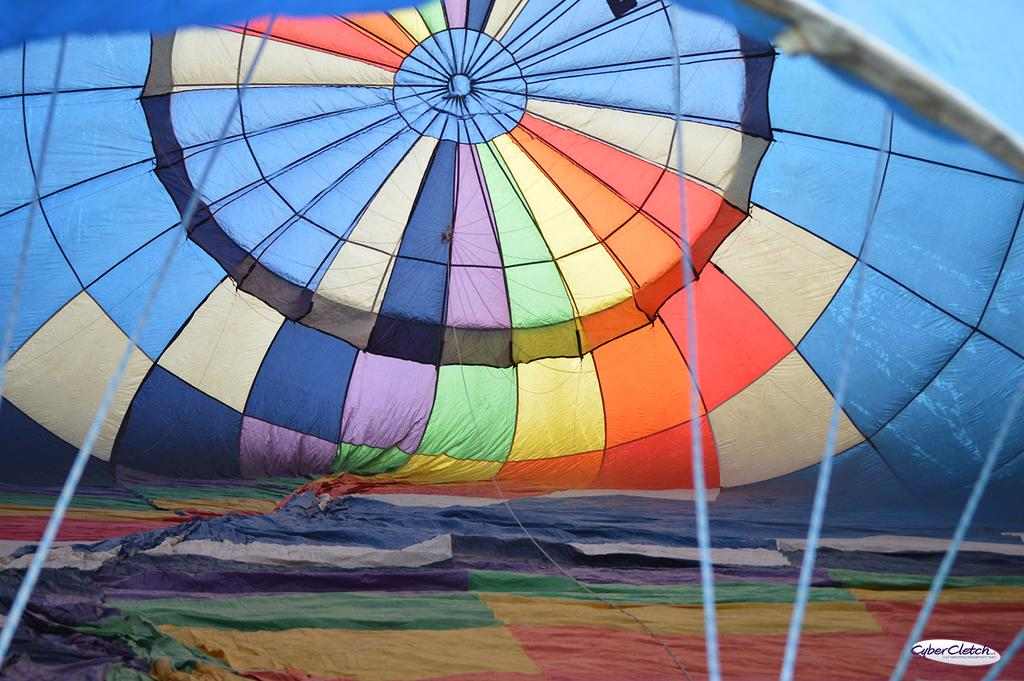What is the main subject of the image? The main subject of the image is a parachute. What type of territory is visible in the image? There is no territory visible in the image; it features a parachute. How many women are present in the image? There is no reference to women in the image, as it only features a parachute. 